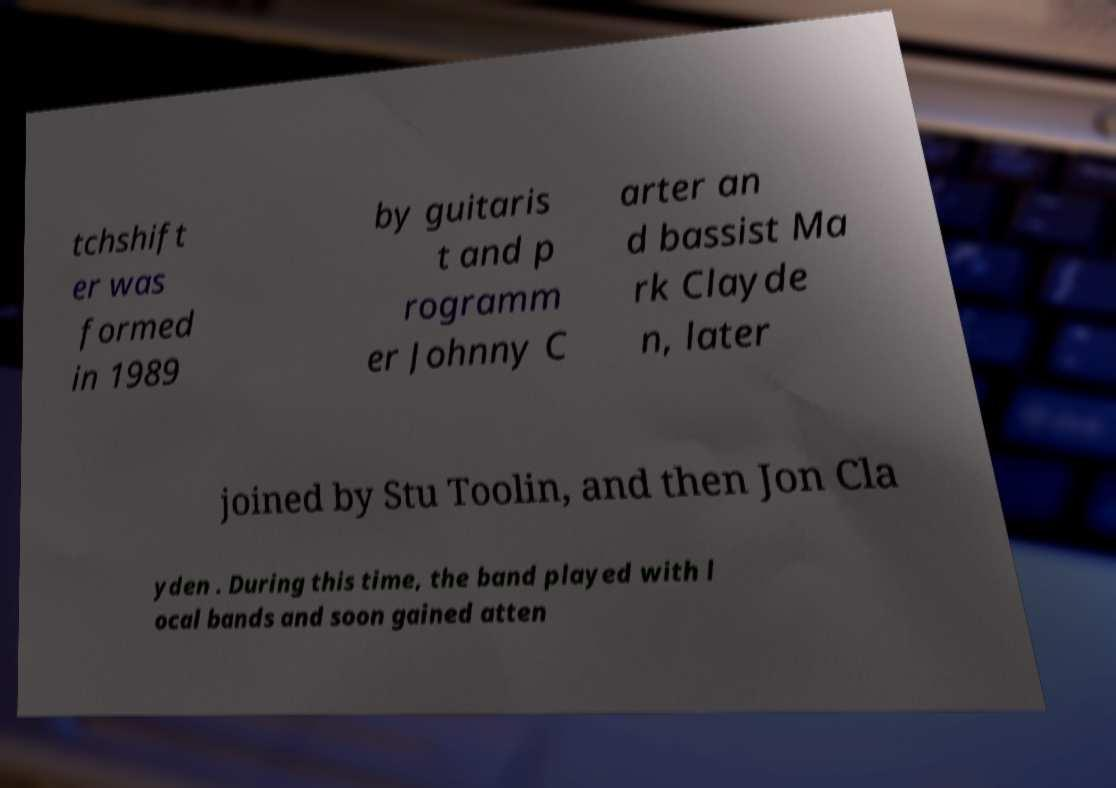There's text embedded in this image that I need extracted. Can you transcribe it verbatim? tchshift er was formed in 1989 by guitaris t and p rogramm er Johnny C arter an d bassist Ma rk Clayde n, later joined by Stu Toolin, and then Jon Cla yden . During this time, the band played with l ocal bands and soon gained atten 